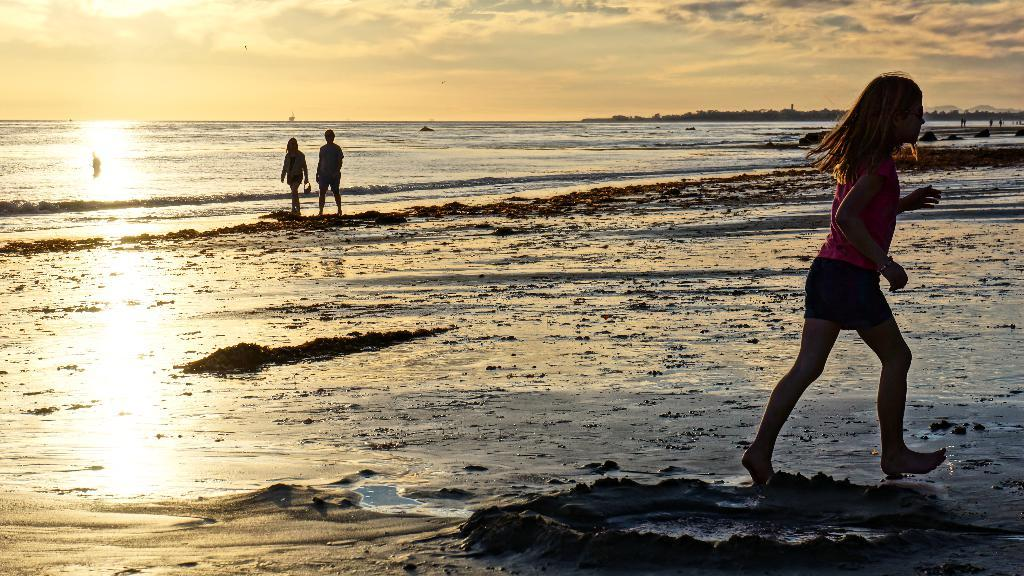How many people are in the image? There are three persons in the image. What is visible in the image besides the people? Water is visible in the image. What can be seen in the background of the image? There are trees and the sky in the background of the image. What is the condition of the sky in the image? Clouds are present in the sky. Can you tell me how many mice are hiding in the trees in the image? There are no mice present in the image; it only features three persons, water, trees, and the sky. 